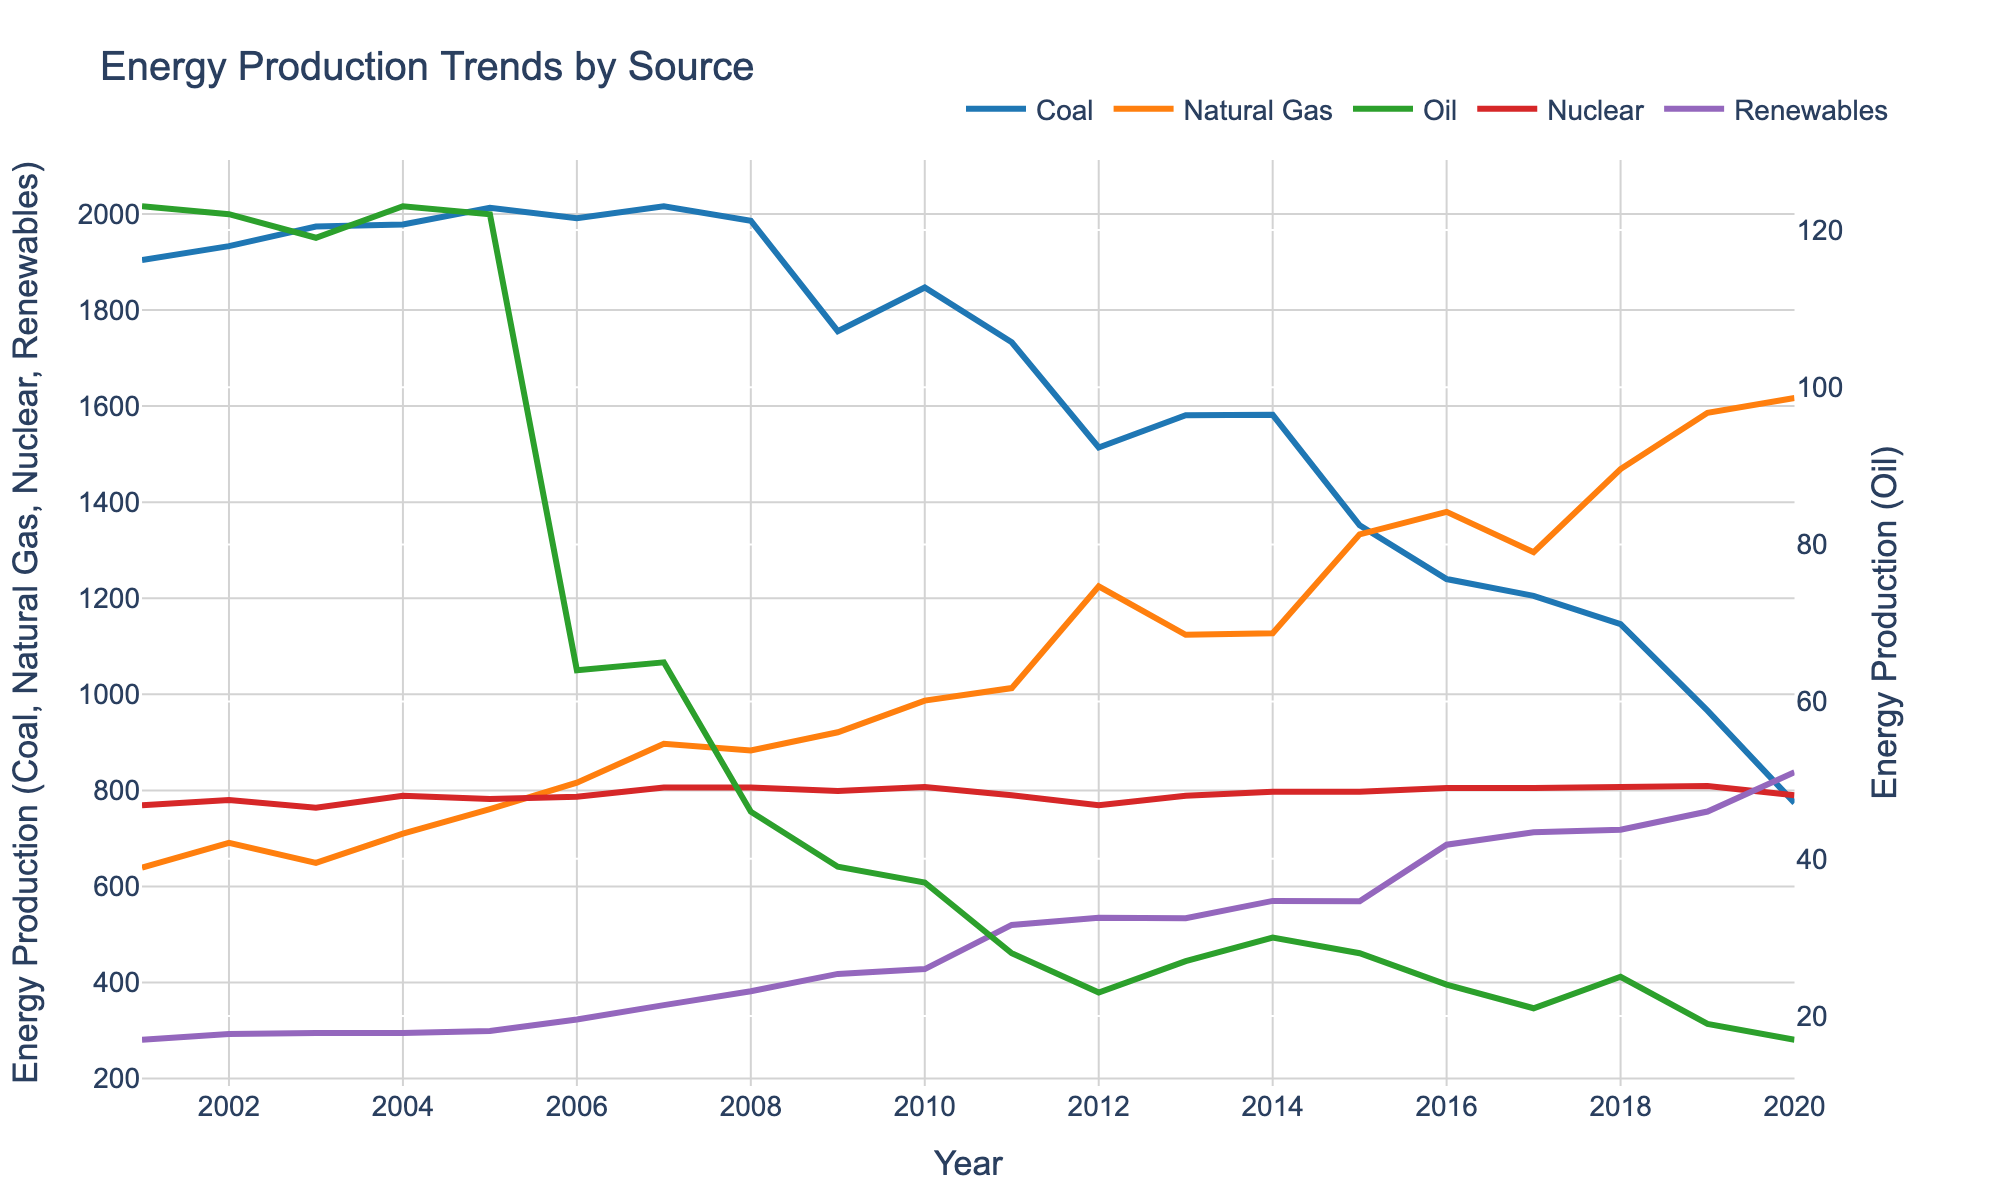What is the trend of coal production over the past 20 years? The data for coal production shows a general downward trend, starting at 1904 in 2001 and ending at 774 in 2020. There are some fluctuations, but the overall trend is a decrease in production.
Answer: Downward trend Which energy source had the highest production in 2020? Observing the graph, we can see that Natural Gas had the highest production in 2020, followed by Coal, Nuclear, Renewables, and Oil.
Answer: Natural Gas How did renewable energy production change from 2001 to 2020? In 2001, renewable energy production was 281, and by 2020, it had increased to 838. This indicates a steady upward trend over the 20 years.
Answer: Increased Compare the production of nuclear energy and oil in 2010. Which one was higher? In 2010, nuclear energy production was 807, whereas oil production was 37. Clearly, nuclear energy production was much higher than oil.
Answer: Nuclear energy What is the average production of natural gas from 2015 to 2020? Sum the production values of natural gas from 2015 to 2020 and divide by the number of years: (1333 + 1380 + 1296 + 1469 + 1586 + 1617) / 6 = 13481 / 6 ≈ 1313.5
Answer: 1313.5 Calculate the total energy production from renewables over 2001, 2005, and 2010. Sum the values of renewable energy production for the years 2001, 2005, and 2010: 281 + 299 + 428 = 1008
Answer: 1008 By how much did nuclear energy production change between 2007 and 2012? In 2007, nuclear energy production was 806, and in 2012, it was 769. The change is 769 - 806 = -37, indicating a decrease of 37.
Answer: Decrease of 37 Which year saw the highest coal production and what was the value? The highest coal production was in 2005, with a value of 2013.
Answer: 2005, 2013 